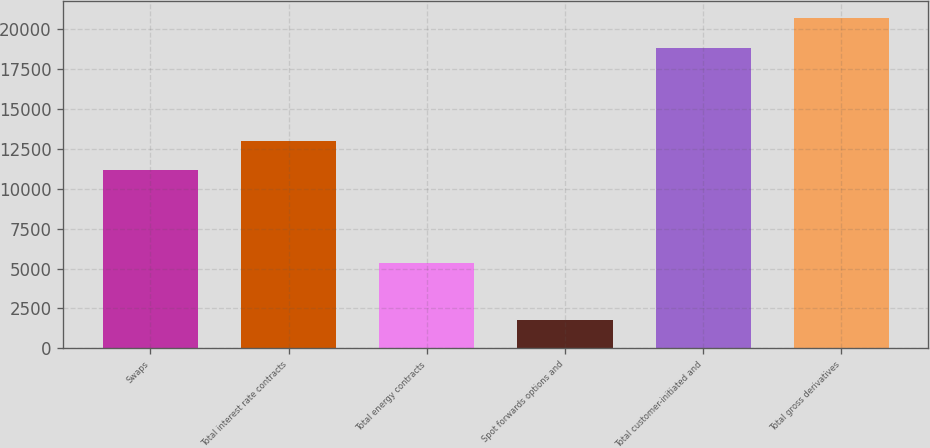Convert chart to OTSL. <chart><loc_0><loc_0><loc_500><loc_500><bar_chart><fcel>Swaps<fcel>Total interest rate contracts<fcel>Total energy contracts<fcel>Spot forwards options and<fcel>Total customer-initiated and<fcel>Total gross derivatives<nl><fcel>11143<fcel>13020.4<fcel>5374<fcel>1764<fcel>18835<fcel>20712.4<nl></chart> 